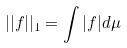<formula> <loc_0><loc_0><loc_500><loc_500>| | f | | _ { 1 } = \int | f | d \mu</formula> 